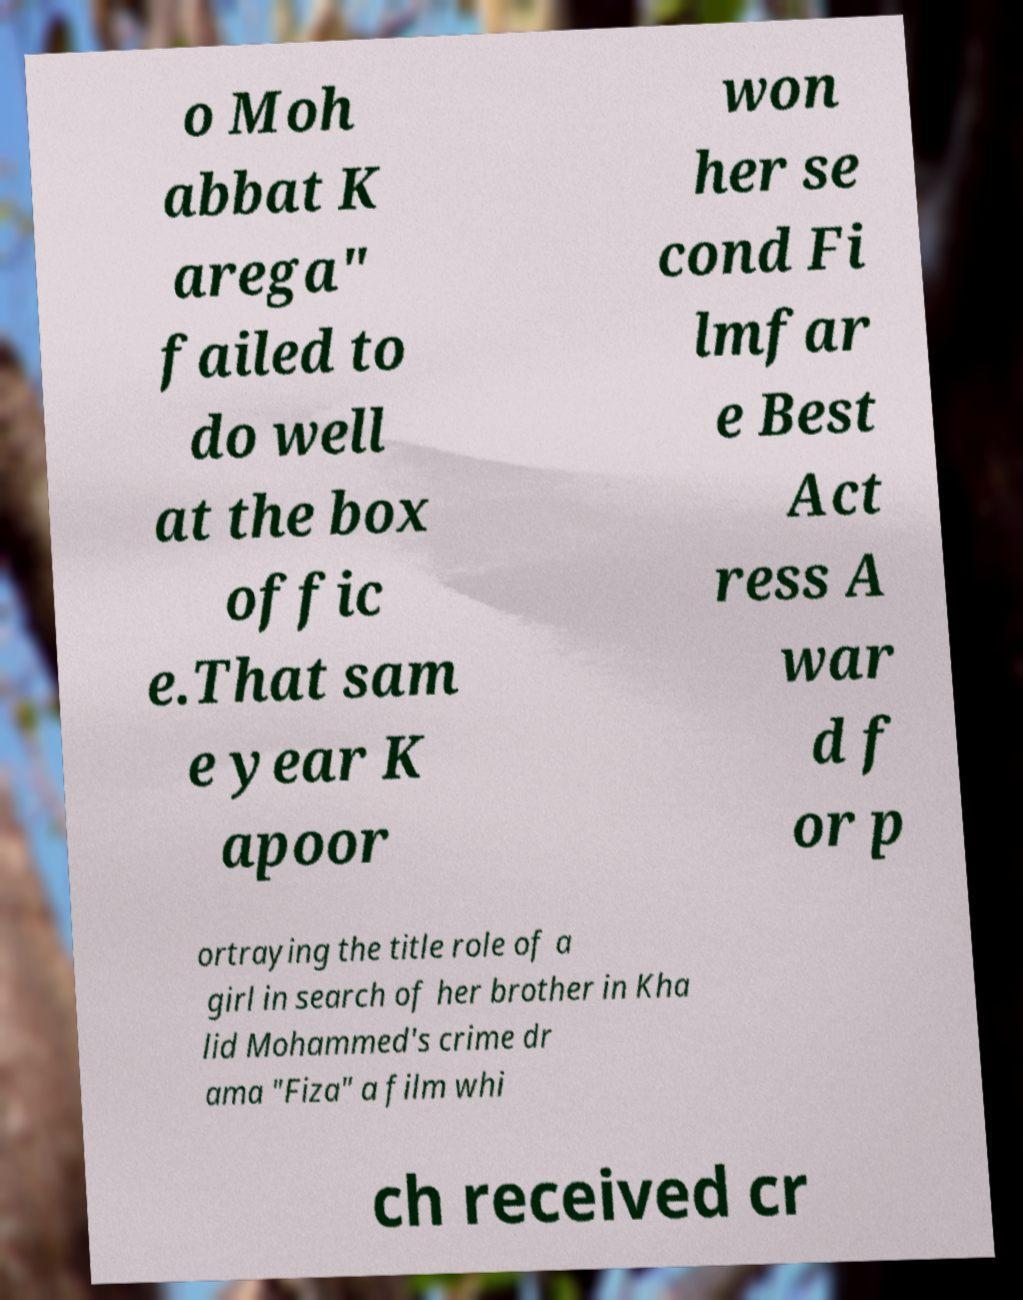What messages or text are displayed in this image? I need them in a readable, typed format. o Moh abbat K arega" failed to do well at the box offic e.That sam e year K apoor won her se cond Fi lmfar e Best Act ress A war d f or p ortraying the title role of a girl in search of her brother in Kha lid Mohammed's crime dr ama "Fiza" a film whi ch received cr 